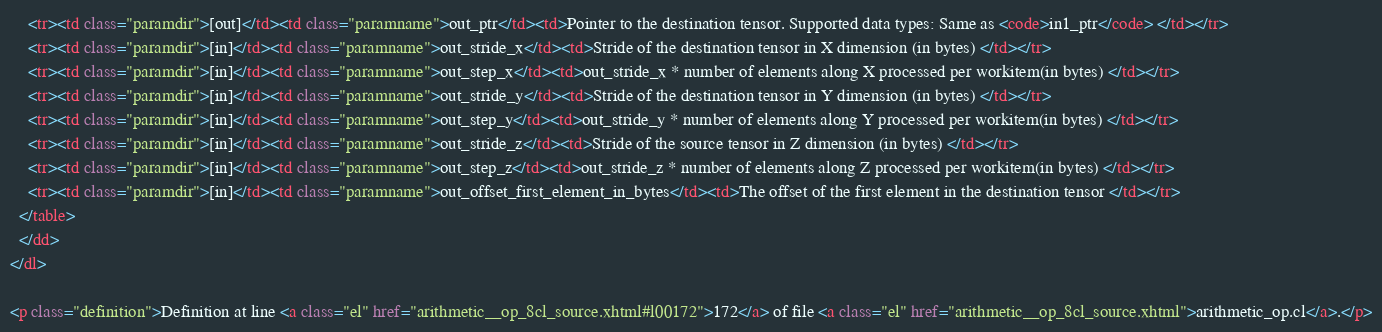<code> <loc_0><loc_0><loc_500><loc_500><_HTML_>    <tr><td class="paramdir">[out]</td><td class="paramname">out_ptr</td><td>Pointer to the destination tensor. Supported data types: Same as <code>in1_ptr</code> </td></tr>
    <tr><td class="paramdir">[in]</td><td class="paramname">out_stride_x</td><td>Stride of the destination tensor in X dimension (in bytes) </td></tr>
    <tr><td class="paramdir">[in]</td><td class="paramname">out_step_x</td><td>out_stride_x * number of elements along X processed per workitem(in bytes) </td></tr>
    <tr><td class="paramdir">[in]</td><td class="paramname">out_stride_y</td><td>Stride of the destination tensor in Y dimension (in bytes) </td></tr>
    <tr><td class="paramdir">[in]</td><td class="paramname">out_step_y</td><td>out_stride_y * number of elements along Y processed per workitem(in bytes) </td></tr>
    <tr><td class="paramdir">[in]</td><td class="paramname">out_stride_z</td><td>Stride of the source tensor in Z dimension (in bytes) </td></tr>
    <tr><td class="paramdir">[in]</td><td class="paramname">out_step_z</td><td>out_stride_z * number of elements along Z processed per workitem(in bytes) </td></tr>
    <tr><td class="paramdir">[in]</td><td class="paramname">out_offset_first_element_in_bytes</td><td>The offset of the first element in the destination tensor </td></tr>
  </table>
  </dd>
</dl>

<p class="definition">Definition at line <a class="el" href="arithmetic__op_8cl_source.xhtml#l00172">172</a> of file <a class="el" href="arithmetic__op_8cl_source.xhtml">arithmetic_op.cl</a>.</p>
</code> 